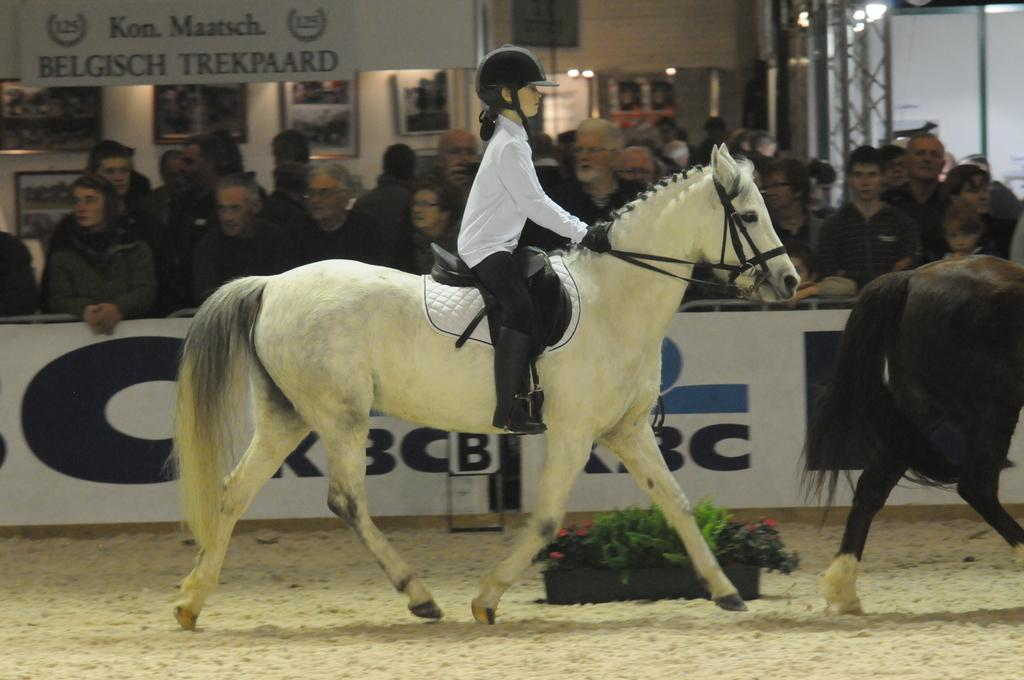Who is the main subject in the image? There is a small girl in the image. What is the girl doing in the image? The girl is riding a horse. Are there any other people present in the image? Yes, there are people watching the girl ride the horse. What can be seen on the ground in the image? There is a flower pot on the ground in the image. What type of stick is the girl using to make the horse jump in the image? There is no stick present in the image, nor is the horse jumping. 